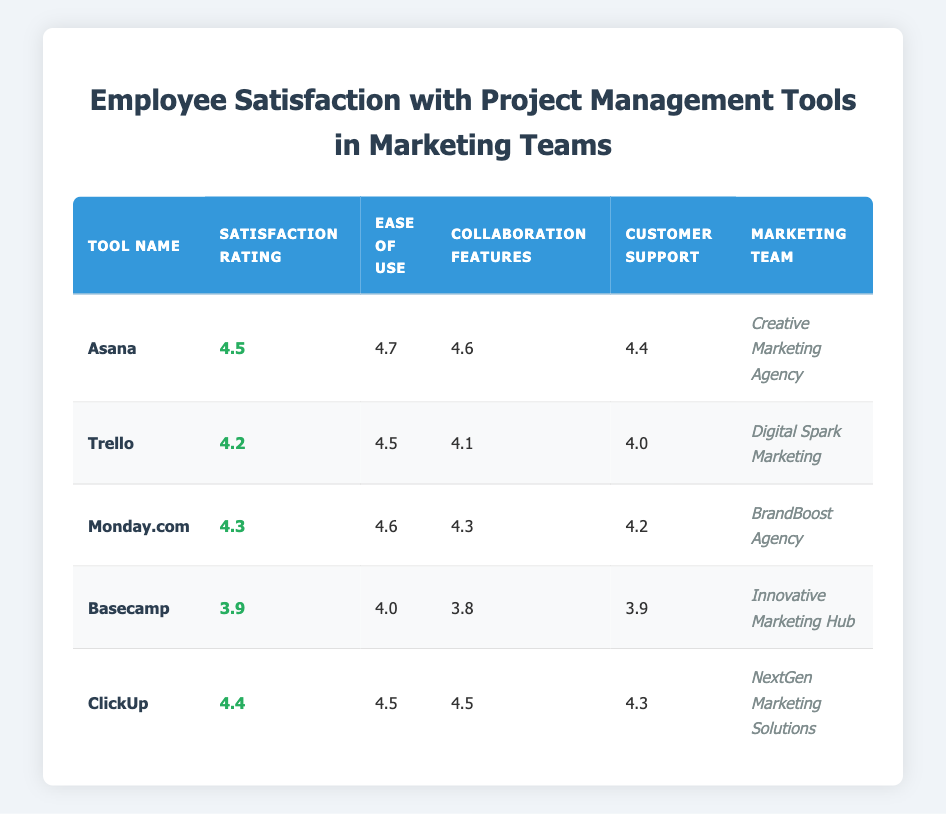What is the satisfaction rating for Asana? The satisfaction rating for Asana is listed directly in the table under the "Satisfaction Rating" column for the tool "Asana." It shows a value of 4.5.
Answer: 4.5 Which tool has the highest ease-of-use rating? By comparing the ease-of-use ratings from the table, Asana has the highest value at 4.7, which is greater than any other tool's ease-of-use rating.
Answer: Asana Is the customer support rating for ClickUp higher than that of Basecamp? Looking at the "Customer Support" ratings for ClickUp and Basecamp, ClickUp has a rating of 4.3 while Basecamp has a rating of 3.9. Since 4.3 is greater than 3.9, customer support for ClickUp is indeed higher.
Answer: Yes What is the average satisfaction rating of all the project management tools listed? To find the average satisfaction rating, we need to sum the ratings for all tools and divide by the number of tools. The total is (4.5 + 4.2 + 4.3 + 3.9 + 4.4) = 21.7, and there are 5 tools, so the average is 21.7 / 5 = 4.34.
Answer: 4.34 Does Trello have better collaboration features than Monday.com? Trello's collaboration features rating is 4.1, while Monday.com has a rating of 4.3. Since 4.1 is less than 4.3, Trello does not have better collaboration features.
Answer: No Which marketing team reported the lowest satisfaction rating with their project management tool? By examining the "Satisfaction Rating" column, Basecamp has the lowest rating at 3.9 compared to the others, making it the marketing team that reported the lowest satisfaction.
Answer: Innovative Marketing Hub How does the customer support rating for Monday.com compare to that of Trello? Monday.com has a customer support rating of 4.2 and Trello has a rating of 4.0. Comparing these two values, 4.2 is greater than 4.0, indicating that Monday.com has better customer support.
Answer: Yes What is the difference between the ease-of-use ratings of ClickUp and Basecamp? ClickUp has an ease-of-use rating of 4.5 and Basecamp has a rating of 4.0. The difference is calculated by subtracting Basecamp's rating from ClickUp's, which results in 4.5 - 4.0 = 0.5.
Answer: 0.5 Which tool, based on this data, appears to have the best overall satisfaction rating, including ease of use, collaboration features, and customer support? Evaluating all ratings, Asana has the high satisfaction rating of 4.5, along with its ease of use (4.7), collaboration features (4.6), and customer support (4.4), showcasing consistent high scores. Thus, Asana appears to have the best overall ratings.
Answer: Asana 